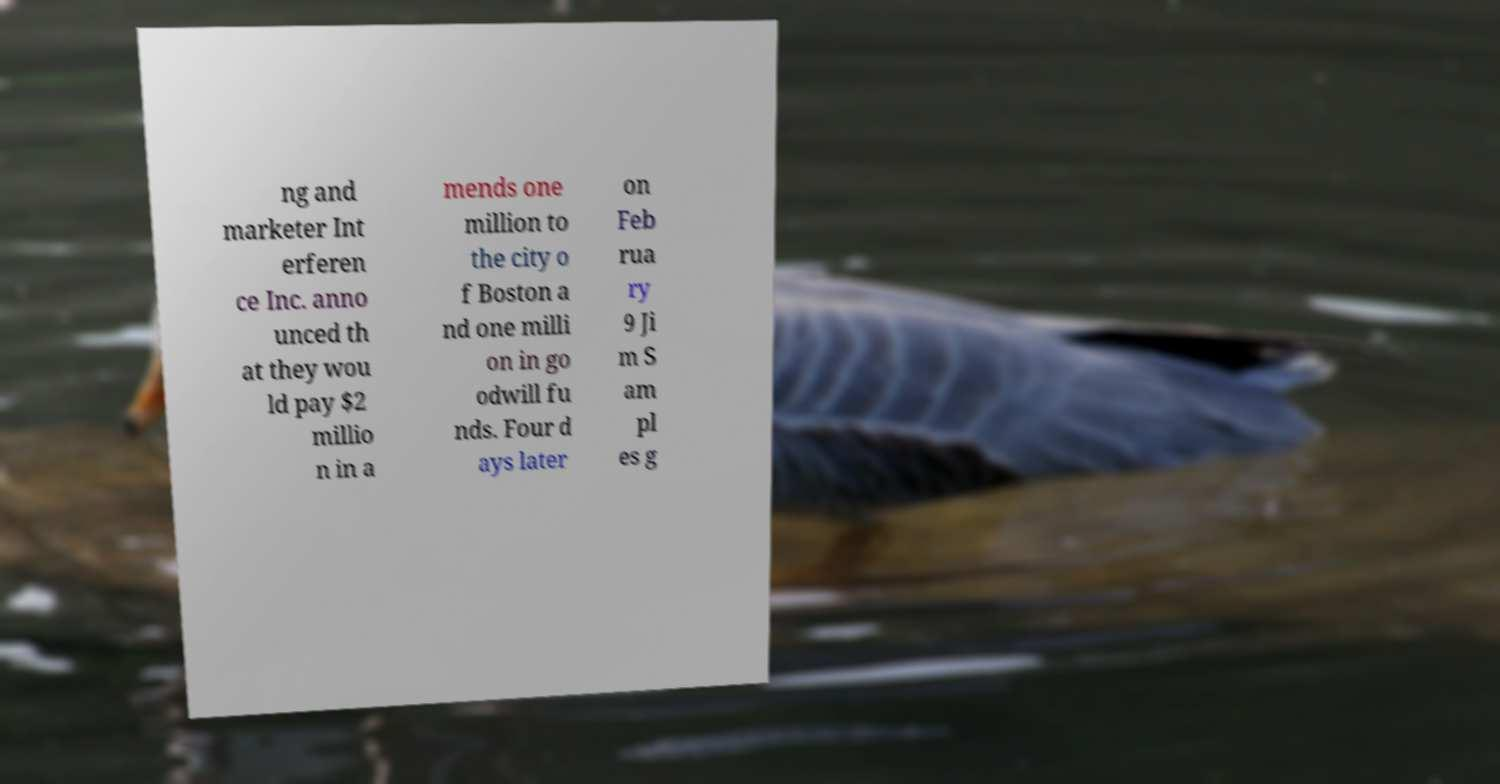I need the written content from this picture converted into text. Can you do that? ng and marketer Int erferen ce Inc. anno unced th at they wou ld pay $2 millio n in a mends one million to the city o f Boston a nd one milli on in go odwill fu nds. Four d ays later on Feb rua ry 9 Ji m S am pl es g 